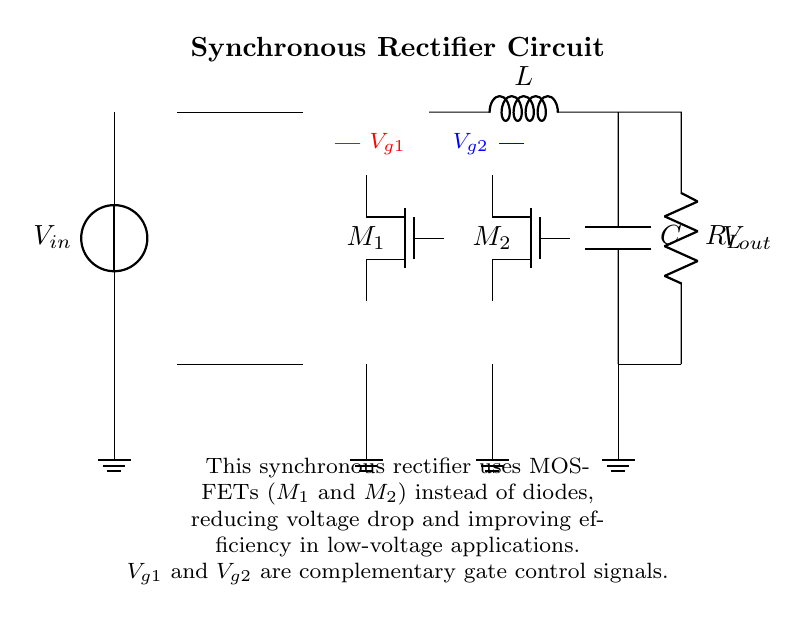What are the main active components in this circuit? The main active components are the two MOSFETs, labeled M1 and M2 in the diagram. These components are responsible for the synchronous rectification, allowing for lower voltage drops compared to diodes.
Answer: MOSFETs What is the purpose of the transformer in this circuit? The transformer is used to step up or step down the input voltage, ensuring the circuit operates within the desired voltage range. In this specific rectifier design, the transformer helps match the input with output requirements.
Answer: Voltage matching What are the control signals labeled in the diagram? The control signals are labeled as Vg1 and Vg2, which are used to drive the gates of the MOSFETs M1 and M2. These signals are critical for synchronously turning the MOSFETs on and off at the correct times during operation.
Answer: Vg1 and Vg2 How does this circuit improve efficiency compared to traditional rectifiers? This circuit improves efficiency by using MOSFETs instead of diodes, which have a much lower forward voltage drop, resulting in less power loss and heat generation, particularly important in low-voltage applications.
Answer: Lower voltage drop What is the output labeled in the diagram? The output is labeled Vout, indicating the point where the output voltage is taken in the circuit. This is the voltage that will be supplied to the load connected across R_L.
Answer: Vout What type of load is represented in the circuit? The load is represented by R_L in the diagram, which indicates a resistive load connected to the output of the synchronous rectifier circuit. The presence of this resistor suggests that the circuit is designed to power devices that consume electrical energy.
Answer: Resistor 